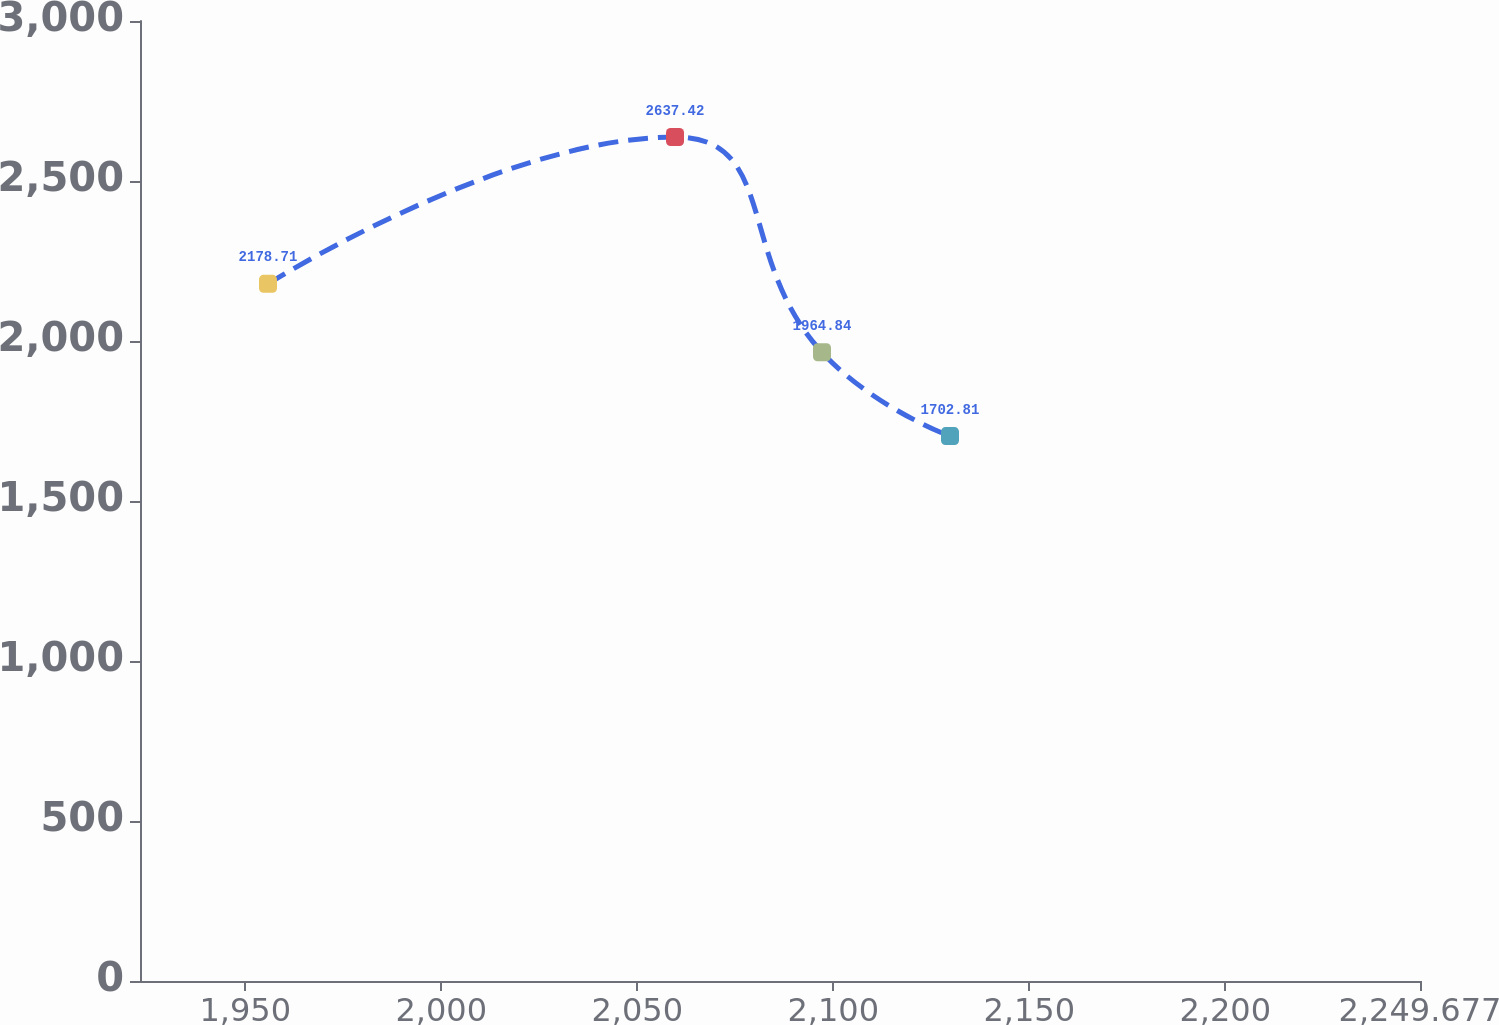<chart> <loc_0><loc_0><loc_500><loc_500><line_chart><ecel><fcel>Unnamed: 1<nl><fcel>1955.8<fcel>2178.71<nl><fcel>2059.63<fcel>2637.42<nl><fcel>2097.13<fcel>1964.84<nl><fcel>2129.78<fcel>1702.81<nl><fcel>2282.33<fcel>1871.38<nl></chart> 